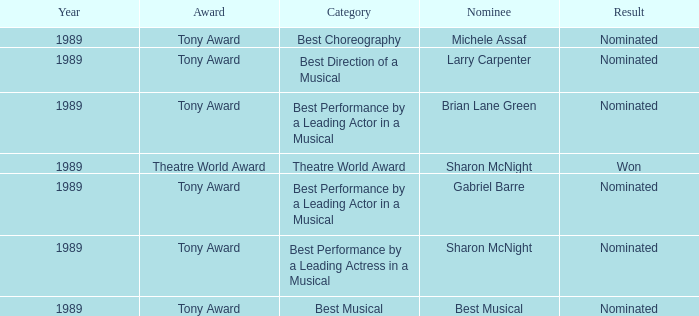What was the nominee of best musical Best Musical. 